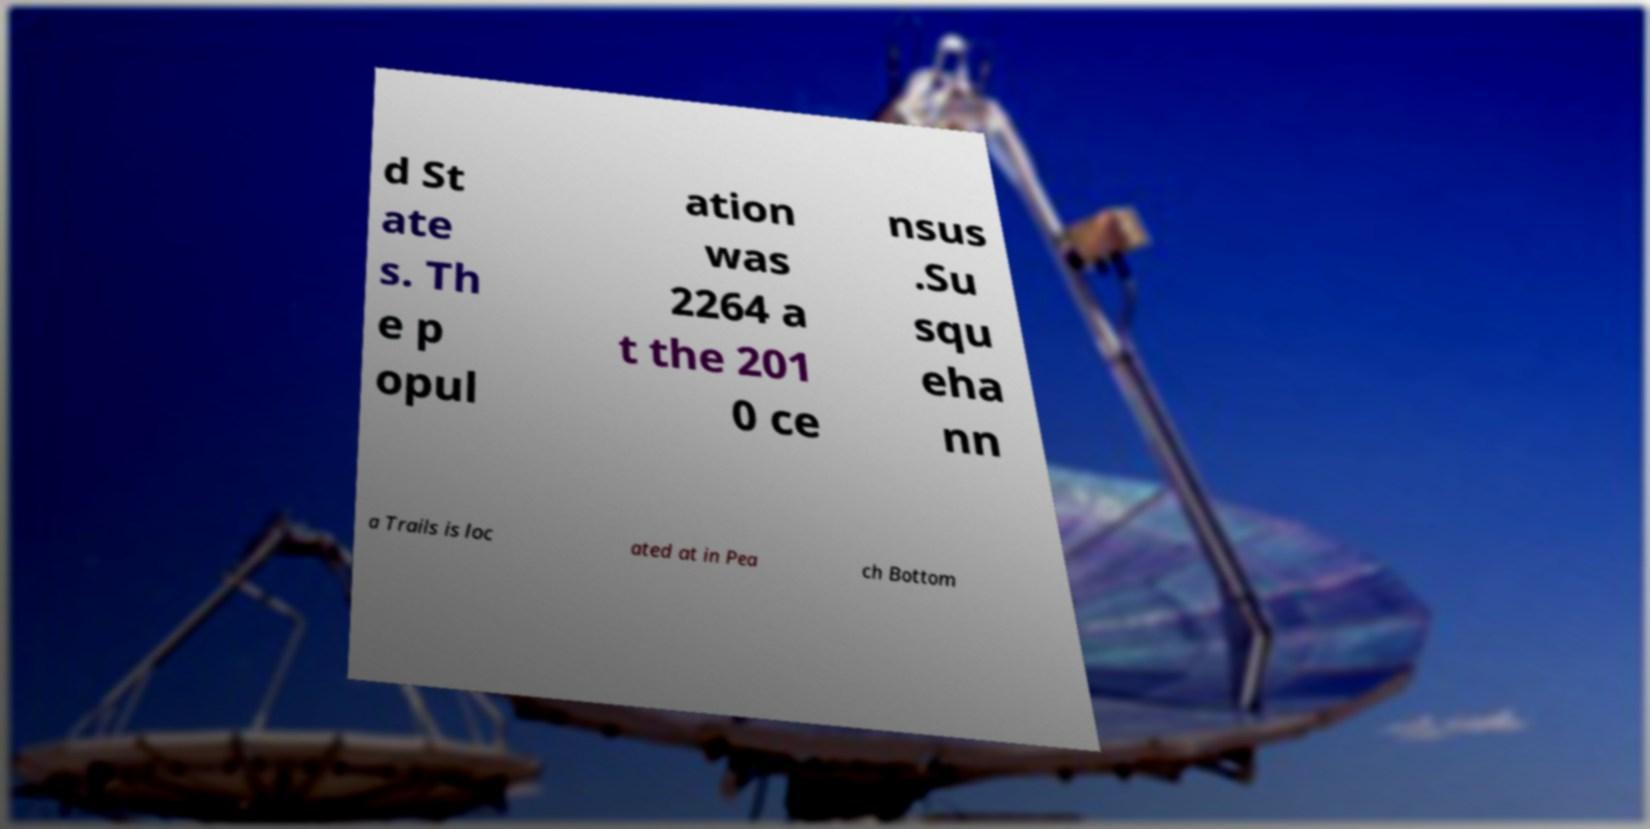Please identify and transcribe the text found in this image. d St ate s. Th e p opul ation was 2264 a t the 201 0 ce nsus .Su squ eha nn a Trails is loc ated at in Pea ch Bottom 